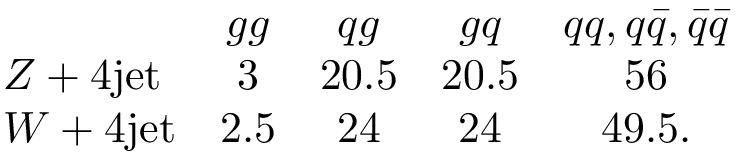Convert formula to latex. <formula><loc_0><loc_0><loc_500><loc_500>\begin{array} { l c c c c & { g g } & { q g } & { g q } & { { q q , q \bar { q } , \bar { q } \bar { q } } } \\ { Z + 4 j e t } & { 3 } & { 2 0 . 5 } & { 2 0 . 5 } & { 5 6 } \\ { W + 4 j e t } & { 2 . 5 } & { 2 4 } & { 2 4 } & { 4 9 . 5 . } \end{array}</formula> 